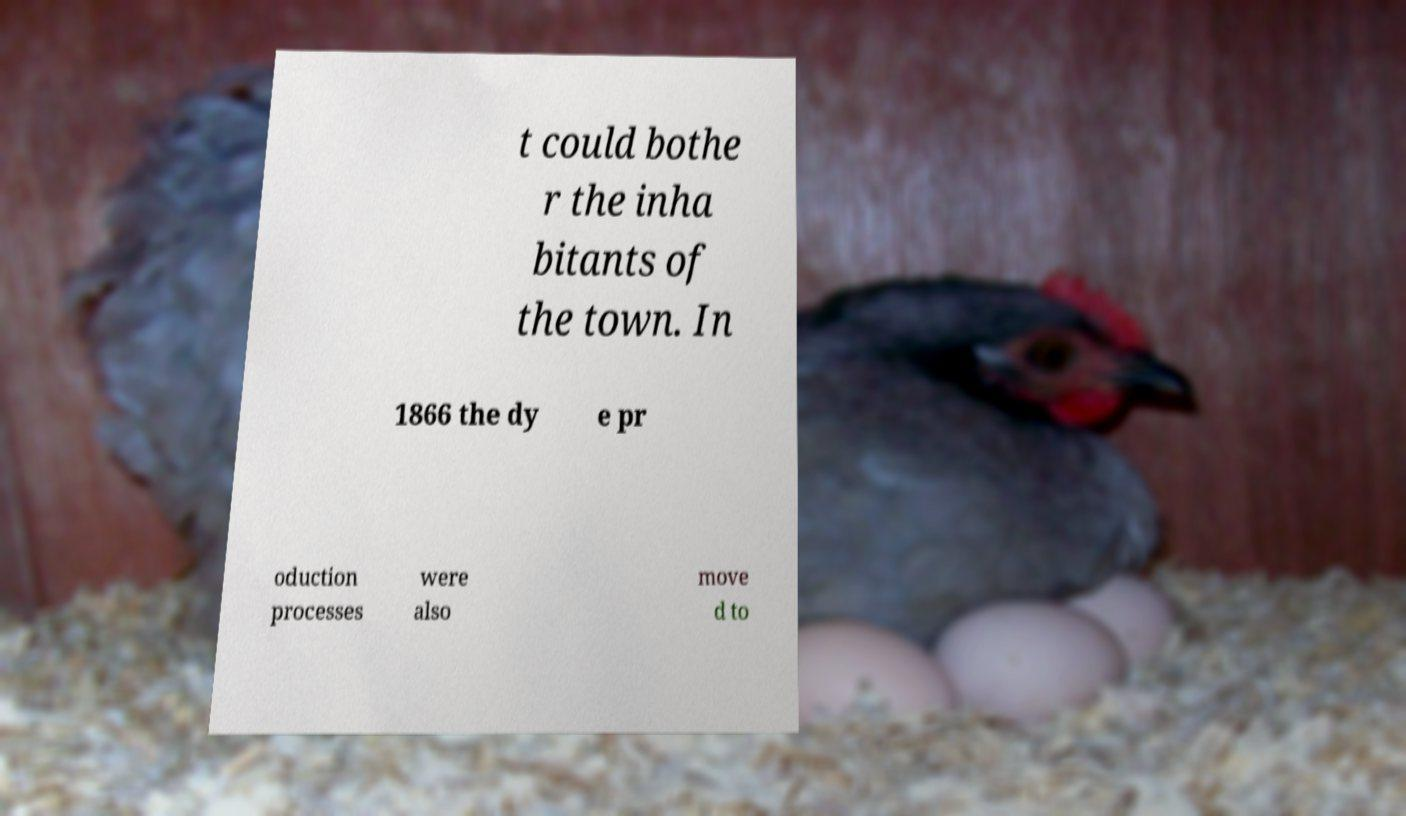What messages or text are displayed in this image? I need them in a readable, typed format. t could bothe r the inha bitants of the town. In 1866 the dy e pr oduction processes were also move d to 